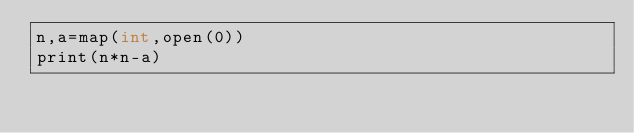<code> <loc_0><loc_0><loc_500><loc_500><_Cython_>n,a=map(int,open(0))
print(n*n-a)</code> 